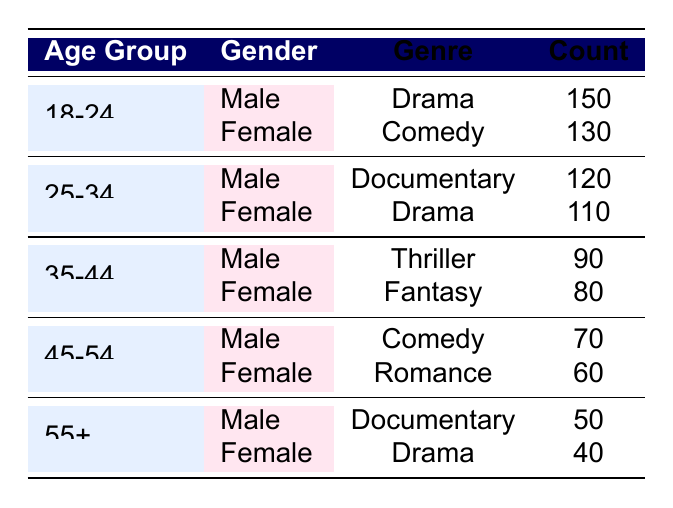What is the most popular genre among males aged 18-24? In the 18-24 age group, looking at the male preferences, the genre with the highest count is Drama with 150. This is the only entry for males in that age group.
Answer: Drama Which genre do females aged 25-34 prefer the most? Among females aged 25-34, the highest count is for Drama with 110, compared to 120 for males in the same age group.
Answer: Drama True or False: The total count of Comedy preferences for males is greater than that for females across all age groups. Looking at the counts for males, we have 70 (45-54) and 150 (18-24). For females, we have 130 (18-24) and 60 (45-54). The total for males is 70 + 150 = 220 and for females is 130 + 60 = 190, making it true that males have a greater count in total.
Answer: True What is the total count of Documentary preferences across all age groups? The counts for Documentary are 120 (25-34, Male) and 50 (55+, Male). Summing these yields 120 + 50 = 170.
Answer: 170 Which age group shows the least preference for Drama? For Drama, we have males aged 18-24 with 150, females aged 25-34 with 110, and females aged 55+ with 40. The lowest count is for females aged 55+ with 40.
Answer: 55+ What are the average counts of preferred genres for females? The total counts for females are 130 (18-24, Comedy) + 110 (25-34, Drama) + 80 (35-44, Fantasy) + 60 (45-54, Romance) + 40 (55+, Drama) = 420 counts. There are 5 entries, so the average is 420/5 = 84.
Answer: 84 